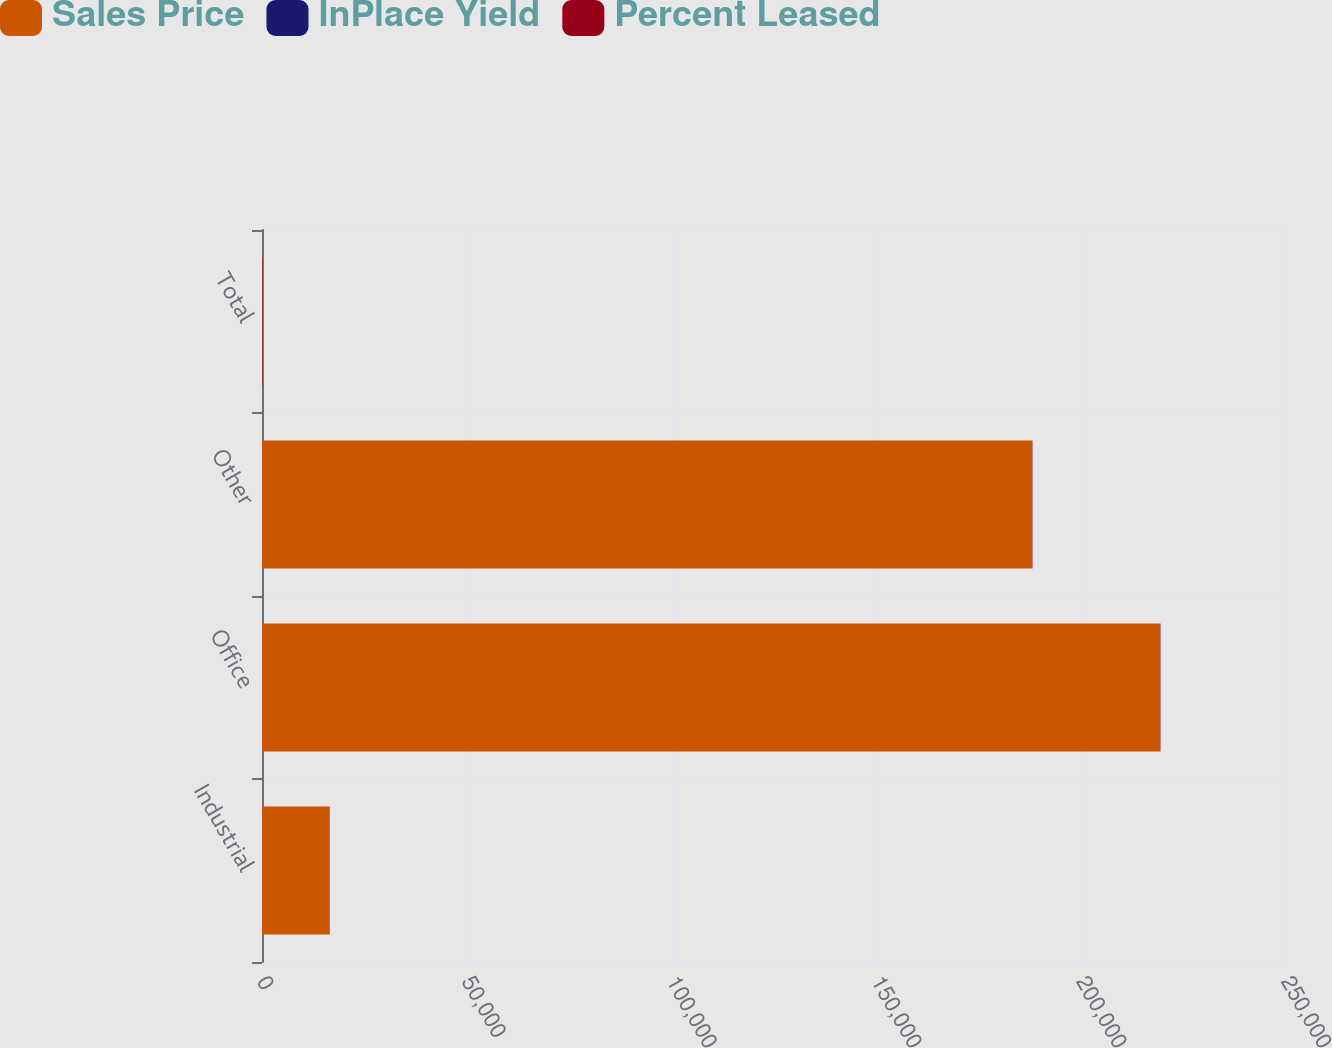Convert chart. <chart><loc_0><loc_0><loc_500><loc_500><stacked_bar_chart><ecel><fcel>Industrial<fcel>Office<fcel>Other<fcel>Total<nl><fcel>Sales Price<fcel>16499<fcel>219254<fcel>188000<fcel>86.8<nl><fcel>InPlace Yield<fcel>6.3<fcel>8.3<fcel>5<fcel>6.6<nl><fcel>Percent Leased<fcel>50.1<fcel>91.8<fcel>89.8<fcel>86.8<nl></chart> 